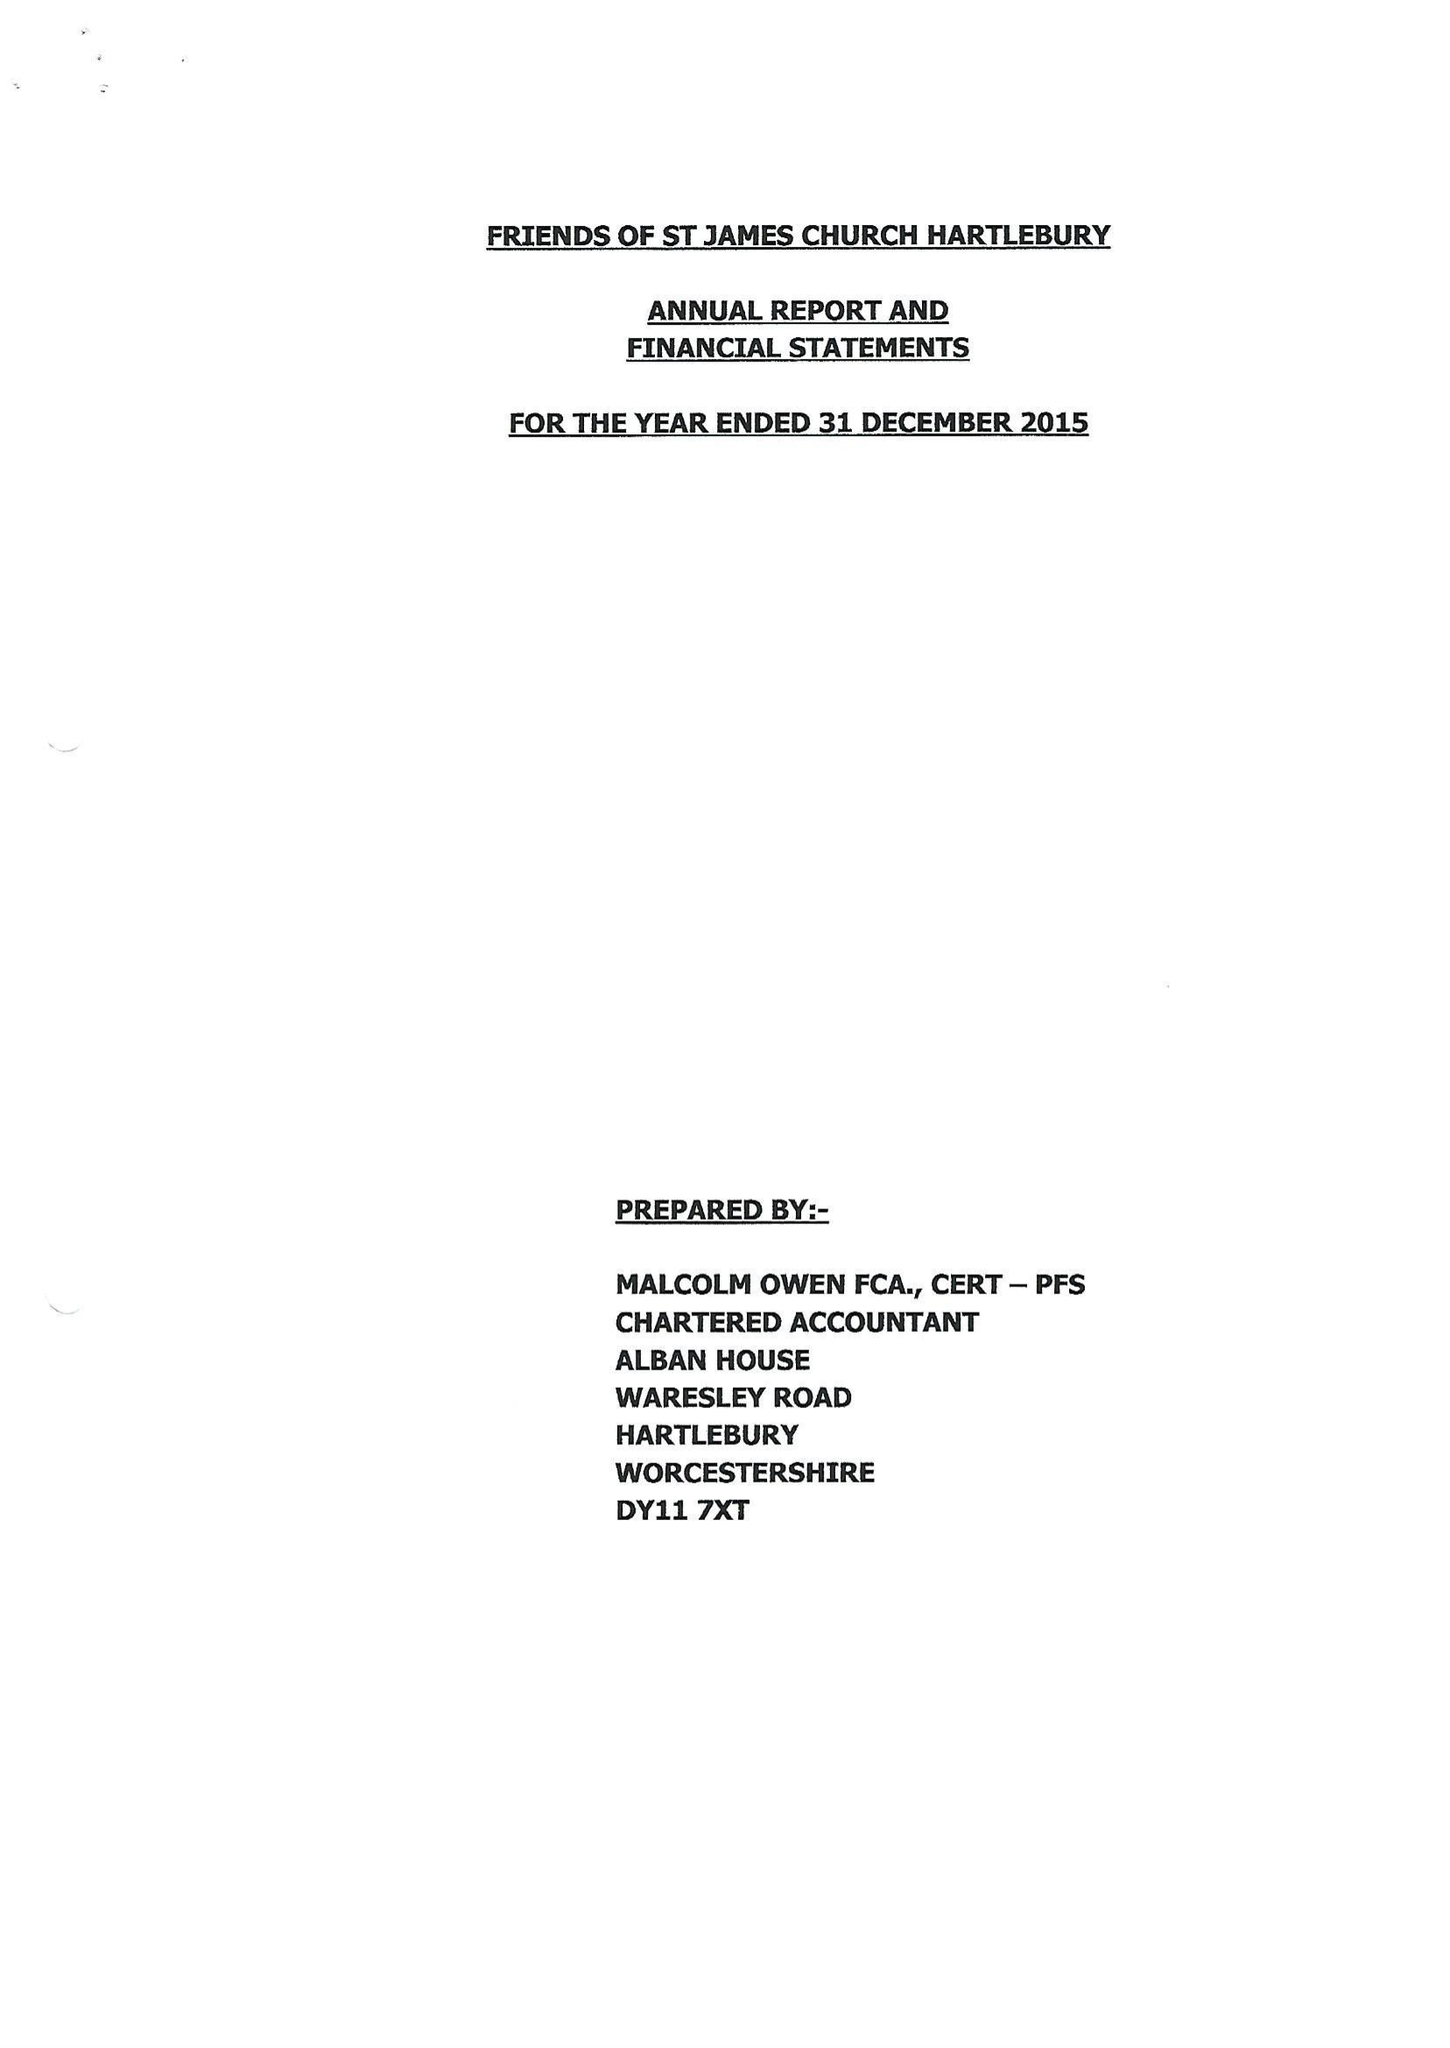What is the value for the charity_name?
Answer the question using a single word or phrase. Friends Of St James Church Hartlebury 